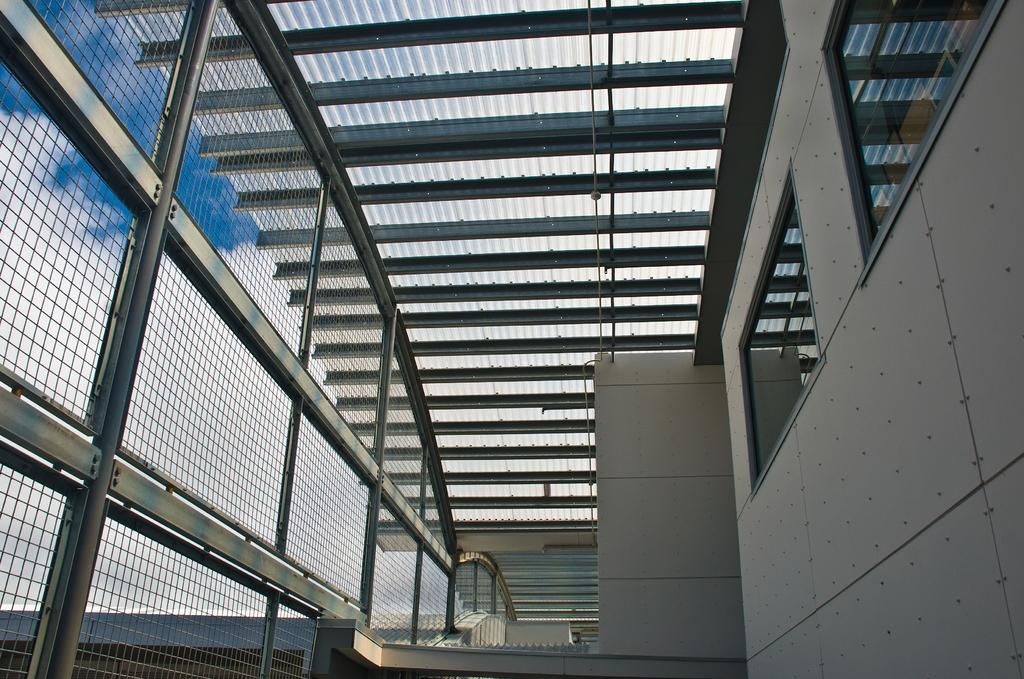What part of a building is shown in the image? The image shows the inner part of a building. What architectural feature can be seen in the image? There are windows visible in the image. What type of cooking appliance is present in the image? There are grills in the image. What can be seen in the background of the image? The sky is visible in the background of the image, with white and blue colors. Can you tell me how many crows are sitting on the grills in the image? There are no crows present in the image; it only shows grills and the inner part of a building. What type of medical facility is depicted in the image? The image does not depict a hospital or any medical facility; it shows the inner part of a building with windows, grills, and the sky in the background. 